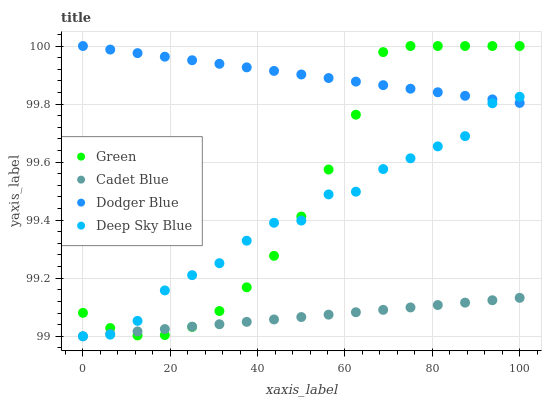Does Cadet Blue have the minimum area under the curve?
Answer yes or no. Yes. Does Dodger Blue have the maximum area under the curve?
Answer yes or no. Yes. Does Green have the minimum area under the curve?
Answer yes or no. No. Does Green have the maximum area under the curve?
Answer yes or no. No. Is Cadet Blue the smoothest?
Answer yes or no. Yes. Is Deep Sky Blue the roughest?
Answer yes or no. Yes. Is Green the smoothest?
Answer yes or no. No. Is Green the roughest?
Answer yes or no. No. Does Cadet Blue have the lowest value?
Answer yes or no. Yes. Does Green have the lowest value?
Answer yes or no. No. Does Green have the highest value?
Answer yes or no. Yes. Does Cadet Blue have the highest value?
Answer yes or no. No. Is Cadet Blue less than Dodger Blue?
Answer yes or no. Yes. Is Dodger Blue greater than Cadet Blue?
Answer yes or no. Yes. Does Green intersect Deep Sky Blue?
Answer yes or no. Yes. Is Green less than Deep Sky Blue?
Answer yes or no. No. Is Green greater than Deep Sky Blue?
Answer yes or no. No. Does Cadet Blue intersect Dodger Blue?
Answer yes or no. No. 